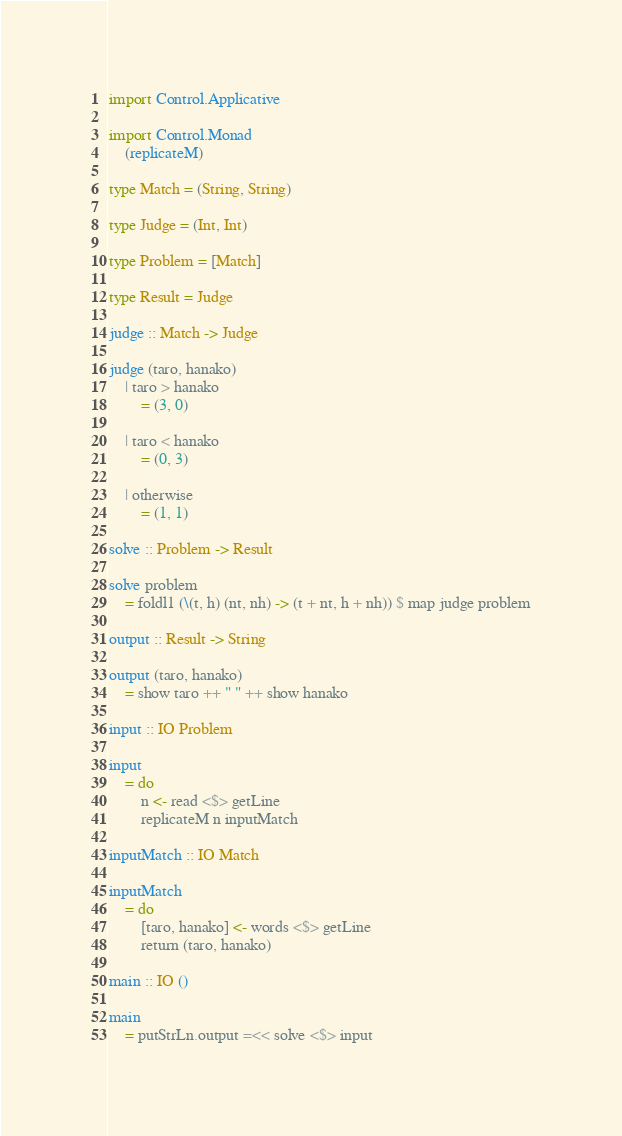Convert code to text. <code><loc_0><loc_0><loc_500><loc_500><_Haskell_>import Control.Applicative

import Control.Monad
    (replicateM)
    
type Match = (String, String)

type Judge = (Int, Int)

type Problem = [Match]

type Result = Judge

judge :: Match -> Judge

judge (taro, hanako)
    | taro > hanako
        = (3, 0)
        
    | taro < hanako
        = (0, 3)
        
    | otherwise
        = (1, 1)
        
solve :: Problem -> Result

solve problem
    = foldl1 (\(t, h) (nt, nh) -> (t + nt, h + nh)) $ map judge problem

output :: Result -> String

output (taro, hanako)
    = show taro ++ " " ++ show hanako
    
input :: IO Problem

input
    = do
        n <- read <$> getLine
        replicateM n inputMatch
        
inputMatch :: IO Match

inputMatch
    = do
        [taro, hanako] <- words <$> getLine
        return (taro, hanako)

main :: IO ()

main
    = putStrLn.output =<< solve <$> input</code> 